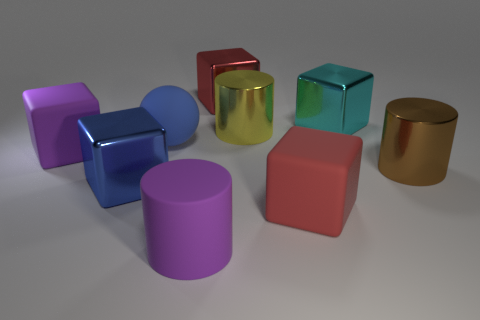There is a big metal cube behind the cyan metal object that is behind the ball; how many cyan objects are left of it?
Offer a terse response. 0. There is a object that is the same color as the rubber cylinder; what size is it?
Give a very brief answer. Large. Is there another tiny yellow sphere that has the same material as the ball?
Make the answer very short. No. Is the material of the purple block the same as the big blue cube?
Offer a terse response. No. How many big shiny cylinders are right of the large matte thing on the right side of the large red shiny object?
Ensure brevity in your answer.  1. How many yellow things are big matte things or big metal cylinders?
Your response must be concise. 1. There is a purple thing that is on the left side of the large purple matte object that is right of the purple rubber thing that is on the left side of the rubber cylinder; what is its shape?
Your answer should be compact. Cube. There is a rubber cylinder that is the same size as the yellow metallic cylinder; what color is it?
Offer a terse response. Purple. How many red matte things have the same shape as the red metallic thing?
Your response must be concise. 1. There is a red matte object; is its size the same as the cylinder that is behind the rubber sphere?
Make the answer very short. Yes. 